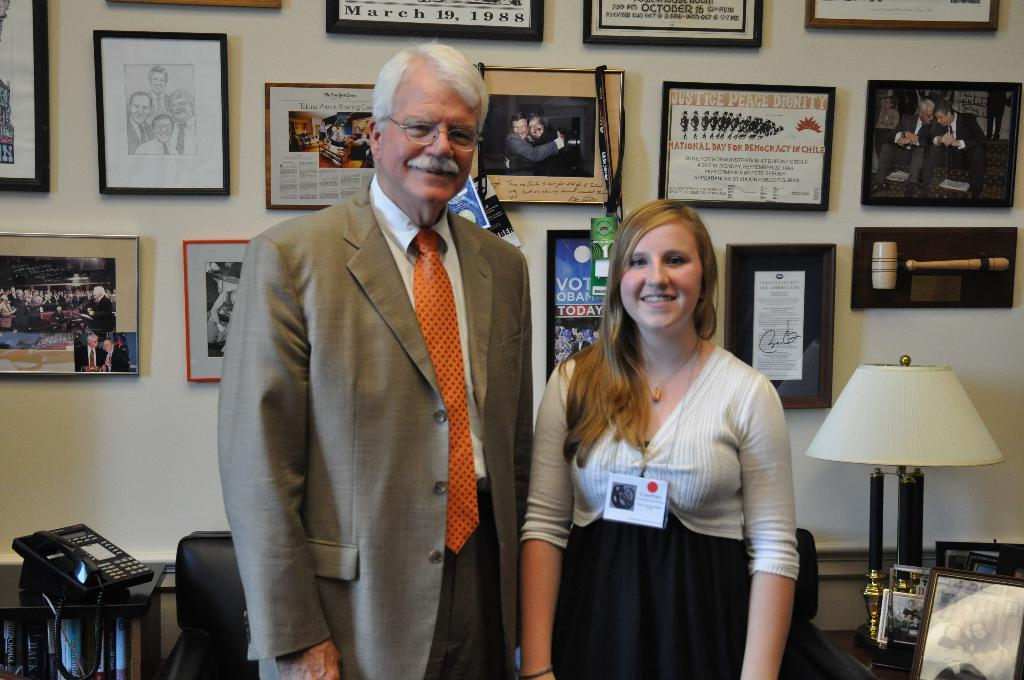Provide a one-sentence caption for the provided image. A man and woman standing in front of plaques where one reads Vote Obama Today. 